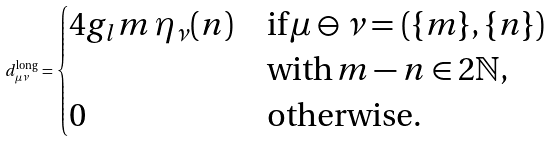<formula> <loc_0><loc_0><loc_500><loc_500>d _ { \mu \nu } ^ { \text {long} } = \begin{cases} 4 g _ { l } m \, \eta _ { \nu } ( n ) & \text {if} \, \mu \ominus \nu = ( \{ m \} , \{ n \} ) \\ & \text {with} \, m - n \in 2 \mathbb { N } , \\ 0 & \text {otherwise} . \end{cases}</formula> 